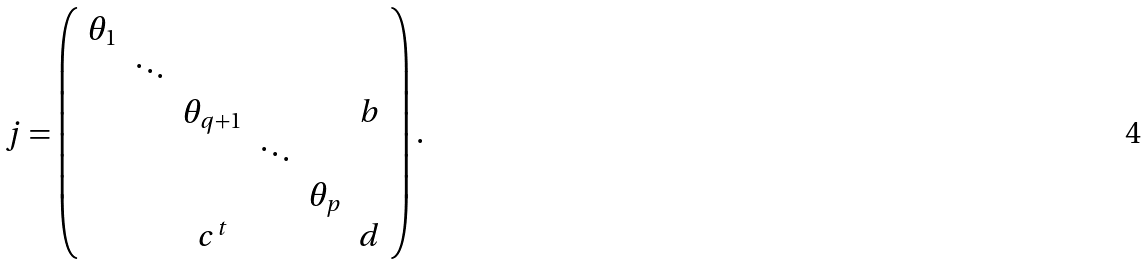Convert formula to latex. <formula><loc_0><loc_0><loc_500><loc_500>j = \left ( \begin{array} { c c c c c c } \theta _ { 1 } & & & & & \\ & \ddots & & & & \\ & & \theta _ { q + 1 } & & & b \\ & & & \ddots & & \\ & & & & \theta _ { p } & \\ & & c ^ { t } & & & d \end{array} \right ) .</formula> 